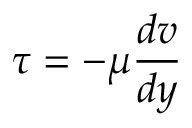Convert formula to latex. <formula><loc_0><loc_0><loc_500><loc_500>\tau = - \mu { \frac { d v } { d y } }</formula> 